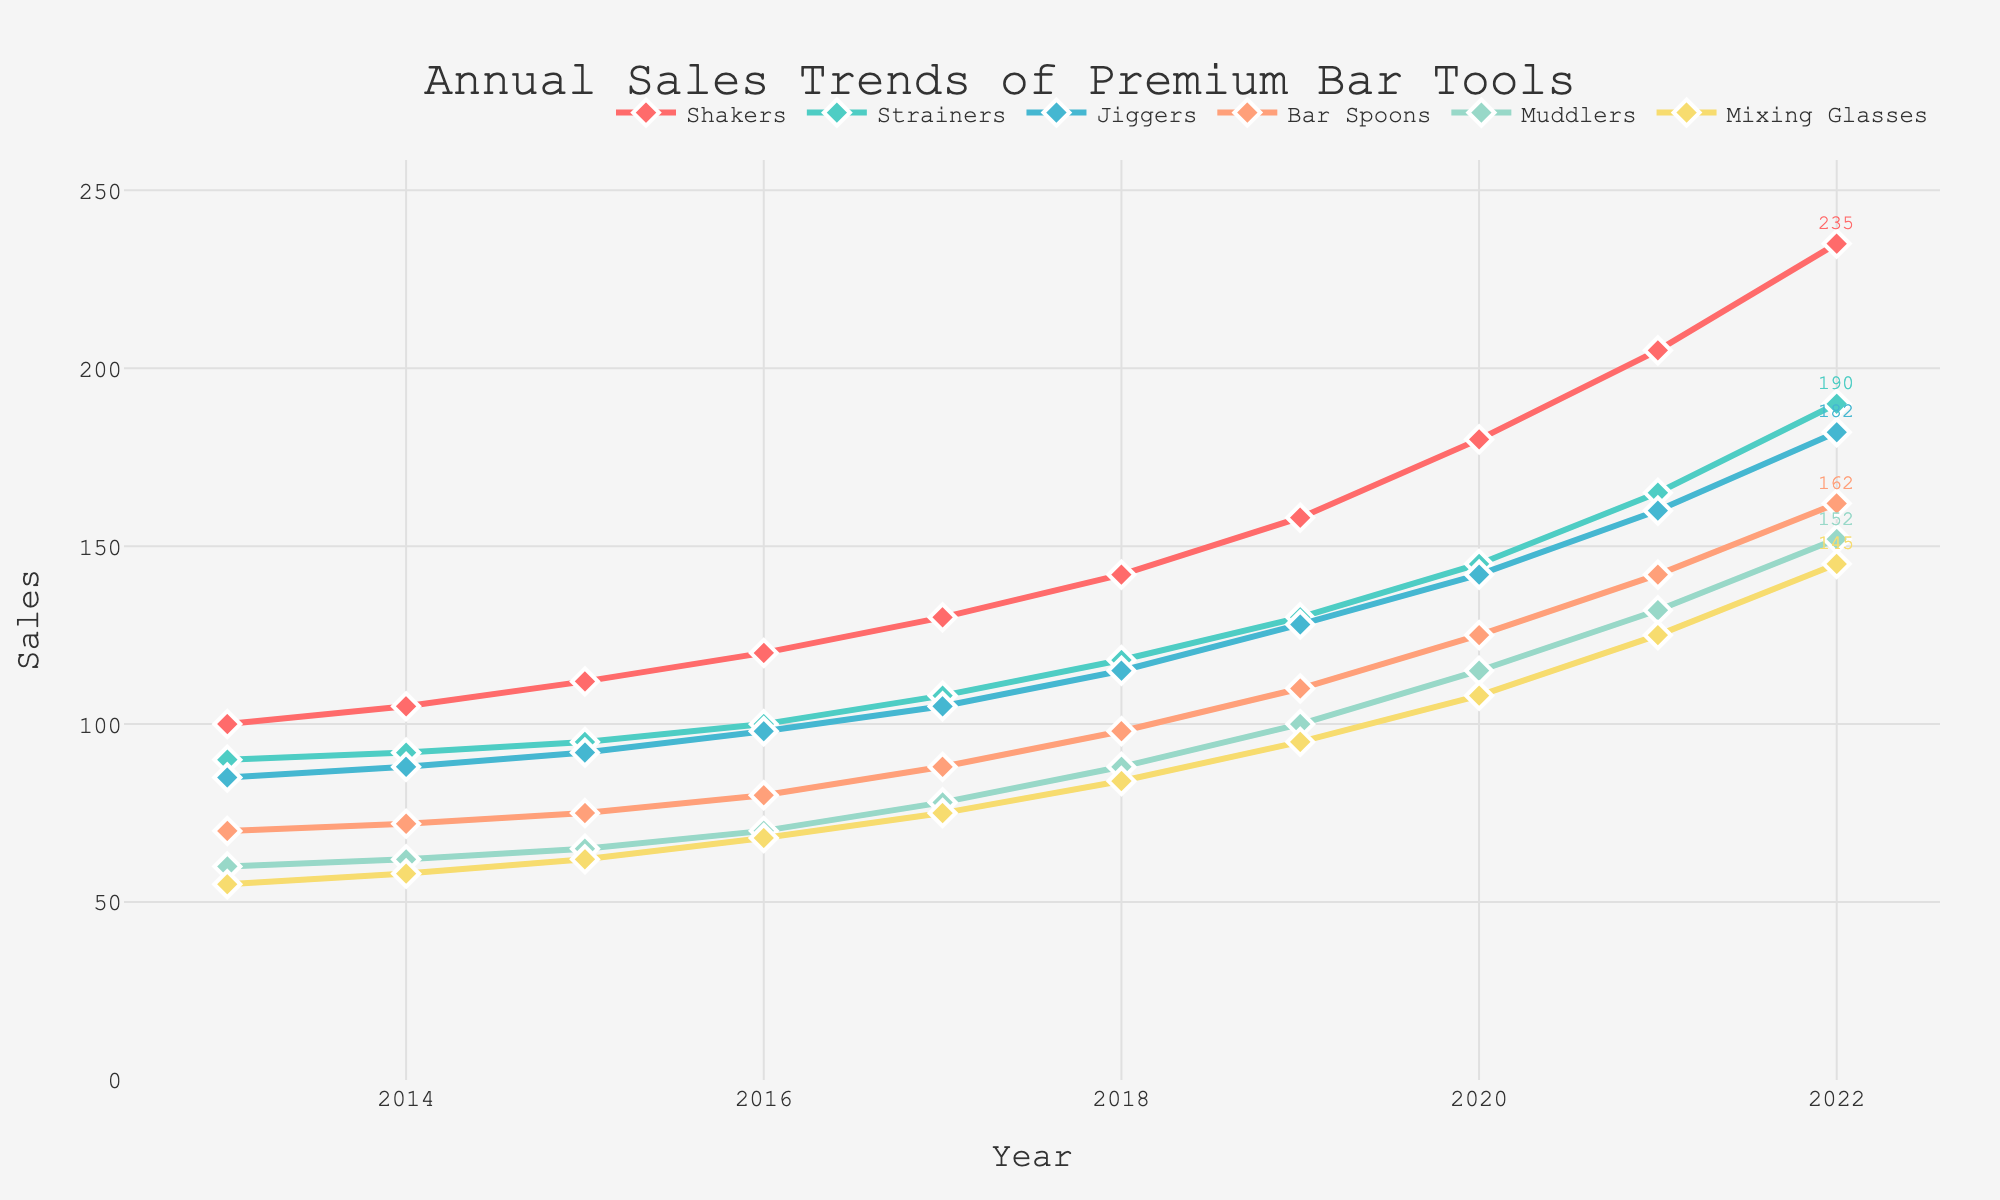Which category had the highest sales in 2022? By observing the placements of the lines and their corresponding year labels in 2022, the line representing "Shakers" is at the highest point, indicating the highest sales.
Answer: Shakers Which bar tool category experienced the largest increase in sales from 2013 to 2022? Calculate the difference in sales for each category from 2013 to 2022 and compare them: Shakers (235-100 = 135), Strainers (190-90 = 100), Jiggers (182-85 = 97), Bar Spoons (162-70 = 92), Muddlers (152-60 = 92), Mixing Glasses (145-55 = 90). Shakers show the largest increase.
Answer: Shakers What is the average annual sales for Bar Spoons between 2013 and 2022? Sum the sales values for Bar Spoons from 2013 to 2022 and divide by the number of years: (70 + 72 + 75 + 80 + 88 + 98 + 110 + 125 + 142 + 162)/10. Calculation: 1022/10 = 102.2.
Answer: 102.2 How did the sales trend for Muddlers compare to that for Mixing Glasses over the years? Observe the relative positions and slopes of the lines representing Muddlers and Mixing Glasses. Both lines show an upward trend, but the Muddlers line generally has a steeper slope and ends higher than the Mixing Glasses line by 2022.
Answer: Muddlers had a steeper increasing trend Between Shakers and Strainers, which category had more fluctuating sales over the decade? By visually comparing the smoothness of the lines, Strainers exhibit more fluctuations in its curve compared to Shakers, which shows a relatively smoother upward trend.
Answer: Strainers What are the visual differences in the annotations for the highest sales values in the figure? Observe the end points of the lines and their annotations. The annotation for Shakers (highest category) is at the topmost position and in red, while the annotations for other categories are lower and in their respective colors.
Answer: Red annotation is the highest for Shakers What is the combined sales number for Muddlers and Jiggers in 2020? Add the sales values for Muddlers and Jiggers in 2020: Muddlers (115) + Jiggers (142). 115 + 142 = 257.
Answer: 257 